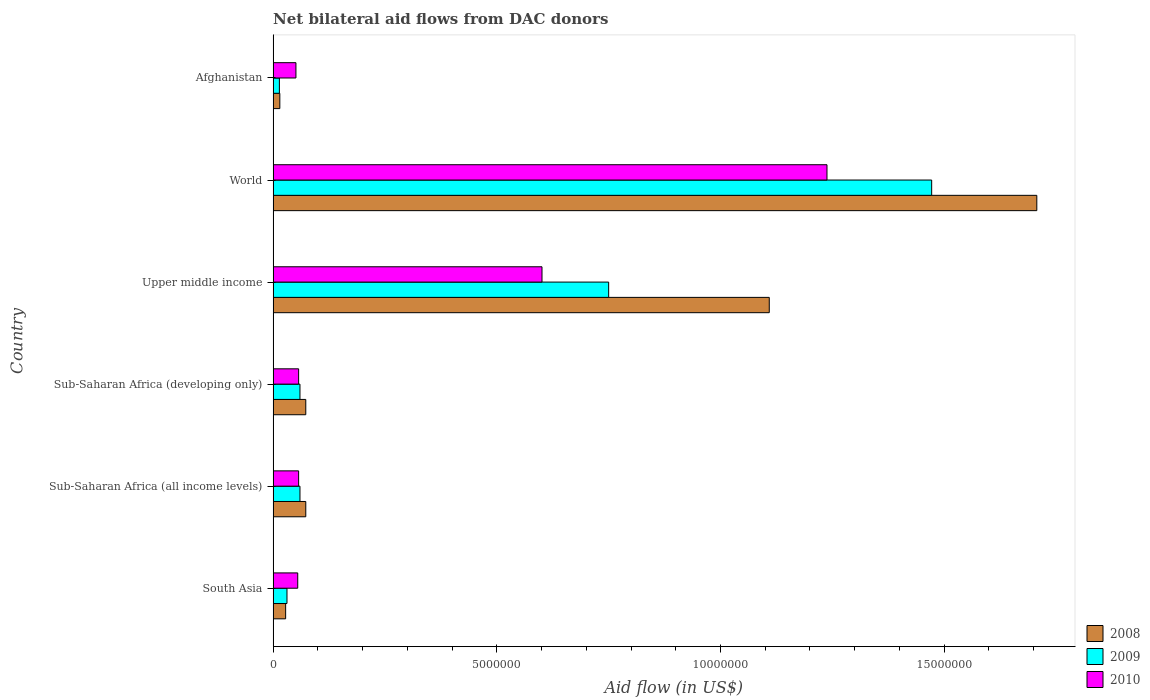How many groups of bars are there?
Provide a short and direct response. 6. Are the number of bars on each tick of the Y-axis equal?
Offer a terse response. Yes. How many bars are there on the 5th tick from the top?
Provide a succinct answer. 3. How many bars are there on the 2nd tick from the bottom?
Your response must be concise. 3. What is the label of the 5th group of bars from the top?
Offer a very short reply. Sub-Saharan Africa (all income levels). What is the net bilateral aid flow in 2009 in Sub-Saharan Africa (all income levels)?
Provide a succinct answer. 6.00e+05. Across all countries, what is the maximum net bilateral aid flow in 2008?
Your answer should be very brief. 1.71e+07. Across all countries, what is the minimum net bilateral aid flow in 2008?
Your response must be concise. 1.50e+05. In which country was the net bilateral aid flow in 2008 maximum?
Your answer should be very brief. World. In which country was the net bilateral aid flow in 2009 minimum?
Provide a succinct answer. Afghanistan. What is the total net bilateral aid flow in 2008 in the graph?
Keep it short and to the point. 3.00e+07. What is the average net bilateral aid flow in 2008 per country?
Make the answer very short. 5.01e+06. What is the difference between the net bilateral aid flow in 2008 and net bilateral aid flow in 2009 in Afghanistan?
Make the answer very short. 10000. What is the ratio of the net bilateral aid flow in 2009 in South Asia to that in Upper middle income?
Provide a succinct answer. 0.04. Is the net bilateral aid flow in 2010 in Sub-Saharan Africa (developing only) less than that in Upper middle income?
Your answer should be compact. Yes. What is the difference between the highest and the second highest net bilateral aid flow in 2010?
Your response must be concise. 6.37e+06. What is the difference between the highest and the lowest net bilateral aid flow in 2010?
Make the answer very short. 1.19e+07. In how many countries, is the net bilateral aid flow in 2010 greater than the average net bilateral aid flow in 2010 taken over all countries?
Give a very brief answer. 2. What does the 2nd bar from the top in South Asia represents?
Provide a succinct answer. 2009. What does the 1st bar from the bottom in South Asia represents?
Give a very brief answer. 2008. How many bars are there?
Make the answer very short. 18. Are all the bars in the graph horizontal?
Your response must be concise. Yes. How many countries are there in the graph?
Provide a short and direct response. 6. What is the difference between two consecutive major ticks on the X-axis?
Keep it short and to the point. 5.00e+06. Does the graph contain any zero values?
Your answer should be very brief. No. Where does the legend appear in the graph?
Your response must be concise. Bottom right. How are the legend labels stacked?
Your response must be concise. Vertical. What is the title of the graph?
Ensure brevity in your answer.  Net bilateral aid flows from DAC donors. Does "1997" appear as one of the legend labels in the graph?
Offer a terse response. No. What is the label or title of the X-axis?
Offer a terse response. Aid flow (in US$). What is the label or title of the Y-axis?
Keep it short and to the point. Country. What is the Aid flow (in US$) of 2010 in South Asia?
Your answer should be compact. 5.50e+05. What is the Aid flow (in US$) of 2008 in Sub-Saharan Africa (all income levels)?
Give a very brief answer. 7.30e+05. What is the Aid flow (in US$) of 2010 in Sub-Saharan Africa (all income levels)?
Provide a short and direct response. 5.70e+05. What is the Aid flow (in US$) in 2008 in Sub-Saharan Africa (developing only)?
Provide a short and direct response. 7.30e+05. What is the Aid flow (in US$) in 2010 in Sub-Saharan Africa (developing only)?
Keep it short and to the point. 5.70e+05. What is the Aid flow (in US$) of 2008 in Upper middle income?
Make the answer very short. 1.11e+07. What is the Aid flow (in US$) of 2009 in Upper middle income?
Provide a succinct answer. 7.50e+06. What is the Aid flow (in US$) of 2010 in Upper middle income?
Provide a short and direct response. 6.01e+06. What is the Aid flow (in US$) in 2008 in World?
Provide a short and direct response. 1.71e+07. What is the Aid flow (in US$) in 2009 in World?
Make the answer very short. 1.47e+07. What is the Aid flow (in US$) in 2010 in World?
Your answer should be compact. 1.24e+07. What is the Aid flow (in US$) of 2008 in Afghanistan?
Provide a short and direct response. 1.50e+05. What is the Aid flow (in US$) in 2010 in Afghanistan?
Offer a very short reply. 5.10e+05. Across all countries, what is the maximum Aid flow (in US$) in 2008?
Provide a short and direct response. 1.71e+07. Across all countries, what is the maximum Aid flow (in US$) in 2009?
Offer a very short reply. 1.47e+07. Across all countries, what is the maximum Aid flow (in US$) in 2010?
Your answer should be compact. 1.24e+07. Across all countries, what is the minimum Aid flow (in US$) in 2009?
Offer a very short reply. 1.40e+05. Across all countries, what is the minimum Aid flow (in US$) of 2010?
Give a very brief answer. 5.10e+05. What is the total Aid flow (in US$) of 2008 in the graph?
Your answer should be very brief. 3.00e+07. What is the total Aid flow (in US$) of 2009 in the graph?
Provide a short and direct response. 2.39e+07. What is the total Aid flow (in US$) of 2010 in the graph?
Your answer should be very brief. 2.06e+07. What is the difference between the Aid flow (in US$) in 2008 in South Asia and that in Sub-Saharan Africa (all income levels)?
Your answer should be very brief. -4.50e+05. What is the difference between the Aid flow (in US$) of 2009 in South Asia and that in Sub-Saharan Africa (all income levels)?
Keep it short and to the point. -2.90e+05. What is the difference between the Aid flow (in US$) of 2010 in South Asia and that in Sub-Saharan Africa (all income levels)?
Your answer should be very brief. -2.00e+04. What is the difference between the Aid flow (in US$) in 2008 in South Asia and that in Sub-Saharan Africa (developing only)?
Make the answer very short. -4.50e+05. What is the difference between the Aid flow (in US$) in 2010 in South Asia and that in Sub-Saharan Africa (developing only)?
Give a very brief answer. -2.00e+04. What is the difference between the Aid flow (in US$) in 2008 in South Asia and that in Upper middle income?
Your response must be concise. -1.08e+07. What is the difference between the Aid flow (in US$) in 2009 in South Asia and that in Upper middle income?
Give a very brief answer. -7.19e+06. What is the difference between the Aid flow (in US$) in 2010 in South Asia and that in Upper middle income?
Offer a terse response. -5.46e+06. What is the difference between the Aid flow (in US$) of 2008 in South Asia and that in World?
Provide a short and direct response. -1.68e+07. What is the difference between the Aid flow (in US$) in 2009 in South Asia and that in World?
Your answer should be compact. -1.44e+07. What is the difference between the Aid flow (in US$) of 2010 in South Asia and that in World?
Your response must be concise. -1.18e+07. What is the difference between the Aid flow (in US$) of 2008 in South Asia and that in Afghanistan?
Offer a terse response. 1.30e+05. What is the difference between the Aid flow (in US$) in 2009 in South Asia and that in Afghanistan?
Make the answer very short. 1.70e+05. What is the difference between the Aid flow (in US$) of 2008 in Sub-Saharan Africa (all income levels) and that in Upper middle income?
Give a very brief answer. -1.04e+07. What is the difference between the Aid flow (in US$) of 2009 in Sub-Saharan Africa (all income levels) and that in Upper middle income?
Keep it short and to the point. -6.90e+06. What is the difference between the Aid flow (in US$) of 2010 in Sub-Saharan Africa (all income levels) and that in Upper middle income?
Your answer should be compact. -5.44e+06. What is the difference between the Aid flow (in US$) of 2008 in Sub-Saharan Africa (all income levels) and that in World?
Give a very brief answer. -1.63e+07. What is the difference between the Aid flow (in US$) in 2009 in Sub-Saharan Africa (all income levels) and that in World?
Your answer should be compact. -1.41e+07. What is the difference between the Aid flow (in US$) in 2010 in Sub-Saharan Africa (all income levels) and that in World?
Offer a terse response. -1.18e+07. What is the difference between the Aid flow (in US$) in 2008 in Sub-Saharan Africa (all income levels) and that in Afghanistan?
Your response must be concise. 5.80e+05. What is the difference between the Aid flow (in US$) of 2009 in Sub-Saharan Africa (all income levels) and that in Afghanistan?
Make the answer very short. 4.60e+05. What is the difference between the Aid flow (in US$) in 2008 in Sub-Saharan Africa (developing only) and that in Upper middle income?
Make the answer very short. -1.04e+07. What is the difference between the Aid flow (in US$) in 2009 in Sub-Saharan Africa (developing only) and that in Upper middle income?
Your answer should be very brief. -6.90e+06. What is the difference between the Aid flow (in US$) of 2010 in Sub-Saharan Africa (developing only) and that in Upper middle income?
Provide a short and direct response. -5.44e+06. What is the difference between the Aid flow (in US$) in 2008 in Sub-Saharan Africa (developing only) and that in World?
Provide a short and direct response. -1.63e+07. What is the difference between the Aid flow (in US$) in 2009 in Sub-Saharan Africa (developing only) and that in World?
Offer a terse response. -1.41e+07. What is the difference between the Aid flow (in US$) of 2010 in Sub-Saharan Africa (developing only) and that in World?
Keep it short and to the point. -1.18e+07. What is the difference between the Aid flow (in US$) of 2008 in Sub-Saharan Africa (developing only) and that in Afghanistan?
Your answer should be very brief. 5.80e+05. What is the difference between the Aid flow (in US$) of 2009 in Sub-Saharan Africa (developing only) and that in Afghanistan?
Provide a succinct answer. 4.60e+05. What is the difference between the Aid flow (in US$) of 2008 in Upper middle income and that in World?
Make the answer very short. -5.98e+06. What is the difference between the Aid flow (in US$) of 2009 in Upper middle income and that in World?
Provide a short and direct response. -7.22e+06. What is the difference between the Aid flow (in US$) of 2010 in Upper middle income and that in World?
Your response must be concise. -6.37e+06. What is the difference between the Aid flow (in US$) of 2008 in Upper middle income and that in Afghanistan?
Keep it short and to the point. 1.09e+07. What is the difference between the Aid flow (in US$) in 2009 in Upper middle income and that in Afghanistan?
Your response must be concise. 7.36e+06. What is the difference between the Aid flow (in US$) in 2010 in Upper middle income and that in Afghanistan?
Offer a terse response. 5.50e+06. What is the difference between the Aid flow (in US$) in 2008 in World and that in Afghanistan?
Give a very brief answer. 1.69e+07. What is the difference between the Aid flow (in US$) of 2009 in World and that in Afghanistan?
Your response must be concise. 1.46e+07. What is the difference between the Aid flow (in US$) in 2010 in World and that in Afghanistan?
Offer a very short reply. 1.19e+07. What is the difference between the Aid flow (in US$) in 2008 in South Asia and the Aid flow (in US$) in 2009 in Sub-Saharan Africa (all income levels)?
Offer a very short reply. -3.20e+05. What is the difference between the Aid flow (in US$) of 2009 in South Asia and the Aid flow (in US$) of 2010 in Sub-Saharan Africa (all income levels)?
Give a very brief answer. -2.60e+05. What is the difference between the Aid flow (in US$) in 2008 in South Asia and the Aid flow (in US$) in 2009 in Sub-Saharan Africa (developing only)?
Provide a short and direct response. -3.20e+05. What is the difference between the Aid flow (in US$) in 2008 in South Asia and the Aid flow (in US$) in 2009 in Upper middle income?
Offer a terse response. -7.22e+06. What is the difference between the Aid flow (in US$) in 2008 in South Asia and the Aid flow (in US$) in 2010 in Upper middle income?
Your response must be concise. -5.73e+06. What is the difference between the Aid flow (in US$) of 2009 in South Asia and the Aid flow (in US$) of 2010 in Upper middle income?
Make the answer very short. -5.70e+06. What is the difference between the Aid flow (in US$) in 2008 in South Asia and the Aid flow (in US$) in 2009 in World?
Offer a very short reply. -1.44e+07. What is the difference between the Aid flow (in US$) in 2008 in South Asia and the Aid flow (in US$) in 2010 in World?
Your answer should be very brief. -1.21e+07. What is the difference between the Aid flow (in US$) of 2009 in South Asia and the Aid flow (in US$) of 2010 in World?
Ensure brevity in your answer.  -1.21e+07. What is the difference between the Aid flow (in US$) in 2008 in South Asia and the Aid flow (in US$) in 2009 in Afghanistan?
Give a very brief answer. 1.40e+05. What is the difference between the Aid flow (in US$) in 2008 in South Asia and the Aid flow (in US$) in 2010 in Afghanistan?
Your answer should be very brief. -2.30e+05. What is the difference between the Aid flow (in US$) in 2008 in Sub-Saharan Africa (all income levels) and the Aid flow (in US$) in 2009 in Sub-Saharan Africa (developing only)?
Keep it short and to the point. 1.30e+05. What is the difference between the Aid flow (in US$) of 2008 in Sub-Saharan Africa (all income levels) and the Aid flow (in US$) of 2010 in Sub-Saharan Africa (developing only)?
Offer a very short reply. 1.60e+05. What is the difference between the Aid flow (in US$) of 2008 in Sub-Saharan Africa (all income levels) and the Aid flow (in US$) of 2009 in Upper middle income?
Make the answer very short. -6.77e+06. What is the difference between the Aid flow (in US$) of 2008 in Sub-Saharan Africa (all income levels) and the Aid flow (in US$) of 2010 in Upper middle income?
Make the answer very short. -5.28e+06. What is the difference between the Aid flow (in US$) of 2009 in Sub-Saharan Africa (all income levels) and the Aid flow (in US$) of 2010 in Upper middle income?
Your answer should be very brief. -5.41e+06. What is the difference between the Aid flow (in US$) of 2008 in Sub-Saharan Africa (all income levels) and the Aid flow (in US$) of 2009 in World?
Your response must be concise. -1.40e+07. What is the difference between the Aid flow (in US$) of 2008 in Sub-Saharan Africa (all income levels) and the Aid flow (in US$) of 2010 in World?
Provide a succinct answer. -1.16e+07. What is the difference between the Aid flow (in US$) in 2009 in Sub-Saharan Africa (all income levels) and the Aid flow (in US$) in 2010 in World?
Your answer should be very brief. -1.18e+07. What is the difference between the Aid flow (in US$) of 2008 in Sub-Saharan Africa (all income levels) and the Aid flow (in US$) of 2009 in Afghanistan?
Keep it short and to the point. 5.90e+05. What is the difference between the Aid flow (in US$) of 2008 in Sub-Saharan Africa (all income levels) and the Aid flow (in US$) of 2010 in Afghanistan?
Keep it short and to the point. 2.20e+05. What is the difference between the Aid flow (in US$) in 2008 in Sub-Saharan Africa (developing only) and the Aid flow (in US$) in 2009 in Upper middle income?
Your response must be concise. -6.77e+06. What is the difference between the Aid flow (in US$) of 2008 in Sub-Saharan Africa (developing only) and the Aid flow (in US$) of 2010 in Upper middle income?
Ensure brevity in your answer.  -5.28e+06. What is the difference between the Aid flow (in US$) in 2009 in Sub-Saharan Africa (developing only) and the Aid flow (in US$) in 2010 in Upper middle income?
Provide a short and direct response. -5.41e+06. What is the difference between the Aid flow (in US$) in 2008 in Sub-Saharan Africa (developing only) and the Aid flow (in US$) in 2009 in World?
Your answer should be compact. -1.40e+07. What is the difference between the Aid flow (in US$) in 2008 in Sub-Saharan Africa (developing only) and the Aid flow (in US$) in 2010 in World?
Offer a very short reply. -1.16e+07. What is the difference between the Aid flow (in US$) in 2009 in Sub-Saharan Africa (developing only) and the Aid flow (in US$) in 2010 in World?
Keep it short and to the point. -1.18e+07. What is the difference between the Aid flow (in US$) in 2008 in Sub-Saharan Africa (developing only) and the Aid flow (in US$) in 2009 in Afghanistan?
Keep it short and to the point. 5.90e+05. What is the difference between the Aid flow (in US$) in 2008 in Sub-Saharan Africa (developing only) and the Aid flow (in US$) in 2010 in Afghanistan?
Your answer should be very brief. 2.20e+05. What is the difference between the Aid flow (in US$) in 2009 in Sub-Saharan Africa (developing only) and the Aid flow (in US$) in 2010 in Afghanistan?
Make the answer very short. 9.00e+04. What is the difference between the Aid flow (in US$) of 2008 in Upper middle income and the Aid flow (in US$) of 2009 in World?
Provide a short and direct response. -3.63e+06. What is the difference between the Aid flow (in US$) of 2008 in Upper middle income and the Aid flow (in US$) of 2010 in World?
Give a very brief answer. -1.29e+06. What is the difference between the Aid flow (in US$) in 2009 in Upper middle income and the Aid flow (in US$) in 2010 in World?
Your answer should be compact. -4.88e+06. What is the difference between the Aid flow (in US$) in 2008 in Upper middle income and the Aid flow (in US$) in 2009 in Afghanistan?
Keep it short and to the point. 1.10e+07. What is the difference between the Aid flow (in US$) in 2008 in Upper middle income and the Aid flow (in US$) in 2010 in Afghanistan?
Ensure brevity in your answer.  1.06e+07. What is the difference between the Aid flow (in US$) in 2009 in Upper middle income and the Aid flow (in US$) in 2010 in Afghanistan?
Give a very brief answer. 6.99e+06. What is the difference between the Aid flow (in US$) of 2008 in World and the Aid flow (in US$) of 2009 in Afghanistan?
Provide a succinct answer. 1.69e+07. What is the difference between the Aid flow (in US$) in 2008 in World and the Aid flow (in US$) in 2010 in Afghanistan?
Make the answer very short. 1.66e+07. What is the difference between the Aid flow (in US$) of 2009 in World and the Aid flow (in US$) of 2010 in Afghanistan?
Provide a succinct answer. 1.42e+07. What is the average Aid flow (in US$) of 2008 per country?
Provide a short and direct response. 5.01e+06. What is the average Aid flow (in US$) of 2009 per country?
Your answer should be very brief. 3.98e+06. What is the average Aid flow (in US$) of 2010 per country?
Offer a terse response. 3.43e+06. What is the difference between the Aid flow (in US$) in 2008 and Aid flow (in US$) in 2009 in Sub-Saharan Africa (all income levels)?
Give a very brief answer. 1.30e+05. What is the difference between the Aid flow (in US$) of 2009 and Aid flow (in US$) of 2010 in Sub-Saharan Africa (all income levels)?
Offer a very short reply. 3.00e+04. What is the difference between the Aid flow (in US$) of 2008 and Aid flow (in US$) of 2009 in Sub-Saharan Africa (developing only)?
Ensure brevity in your answer.  1.30e+05. What is the difference between the Aid flow (in US$) of 2008 and Aid flow (in US$) of 2010 in Sub-Saharan Africa (developing only)?
Offer a very short reply. 1.60e+05. What is the difference between the Aid flow (in US$) of 2008 and Aid flow (in US$) of 2009 in Upper middle income?
Make the answer very short. 3.59e+06. What is the difference between the Aid flow (in US$) in 2008 and Aid flow (in US$) in 2010 in Upper middle income?
Offer a terse response. 5.08e+06. What is the difference between the Aid flow (in US$) in 2009 and Aid flow (in US$) in 2010 in Upper middle income?
Offer a terse response. 1.49e+06. What is the difference between the Aid flow (in US$) in 2008 and Aid flow (in US$) in 2009 in World?
Keep it short and to the point. 2.35e+06. What is the difference between the Aid flow (in US$) in 2008 and Aid flow (in US$) in 2010 in World?
Your response must be concise. 4.69e+06. What is the difference between the Aid flow (in US$) in 2009 and Aid flow (in US$) in 2010 in World?
Give a very brief answer. 2.34e+06. What is the difference between the Aid flow (in US$) of 2008 and Aid flow (in US$) of 2009 in Afghanistan?
Ensure brevity in your answer.  10000. What is the difference between the Aid flow (in US$) in 2008 and Aid flow (in US$) in 2010 in Afghanistan?
Your answer should be compact. -3.60e+05. What is the difference between the Aid flow (in US$) in 2009 and Aid flow (in US$) in 2010 in Afghanistan?
Make the answer very short. -3.70e+05. What is the ratio of the Aid flow (in US$) of 2008 in South Asia to that in Sub-Saharan Africa (all income levels)?
Keep it short and to the point. 0.38. What is the ratio of the Aid flow (in US$) in 2009 in South Asia to that in Sub-Saharan Africa (all income levels)?
Your answer should be very brief. 0.52. What is the ratio of the Aid flow (in US$) in 2010 in South Asia to that in Sub-Saharan Africa (all income levels)?
Provide a succinct answer. 0.96. What is the ratio of the Aid flow (in US$) in 2008 in South Asia to that in Sub-Saharan Africa (developing only)?
Keep it short and to the point. 0.38. What is the ratio of the Aid flow (in US$) of 2009 in South Asia to that in Sub-Saharan Africa (developing only)?
Offer a very short reply. 0.52. What is the ratio of the Aid flow (in US$) of 2010 in South Asia to that in Sub-Saharan Africa (developing only)?
Your response must be concise. 0.96. What is the ratio of the Aid flow (in US$) in 2008 in South Asia to that in Upper middle income?
Your answer should be very brief. 0.03. What is the ratio of the Aid flow (in US$) in 2009 in South Asia to that in Upper middle income?
Your answer should be very brief. 0.04. What is the ratio of the Aid flow (in US$) of 2010 in South Asia to that in Upper middle income?
Ensure brevity in your answer.  0.09. What is the ratio of the Aid flow (in US$) in 2008 in South Asia to that in World?
Offer a terse response. 0.02. What is the ratio of the Aid flow (in US$) in 2009 in South Asia to that in World?
Keep it short and to the point. 0.02. What is the ratio of the Aid flow (in US$) of 2010 in South Asia to that in World?
Provide a succinct answer. 0.04. What is the ratio of the Aid flow (in US$) of 2008 in South Asia to that in Afghanistan?
Ensure brevity in your answer.  1.87. What is the ratio of the Aid flow (in US$) in 2009 in South Asia to that in Afghanistan?
Provide a short and direct response. 2.21. What is the ratio of the Aid flow (in US$) of 2010 in South Asia to that in Afghanistan?
Give a very brief answer. 1.08. What is the ratio of the Aid flow (in US$) in 2008 in Sub-Saharan Africa (all income levels) to that in Sub-Saharan Africa (developing only)?
Provide a short and direct response. 1. What is the ratio of the Aid flow (in US$) of 2010 in Sub-Saharan Africa (all income levels) to that in Sub-Saharan Africa (developing only)?
Keep it short and to the point. 1. What is the ratio of the Aid flow (in US$) of 2008 in Sub-Saharan Africa (all income levels) to that in Upper middle income?
Offer a very short reply. 0.07. What is the ratio of the Aid flow (in US$) in 2009 in Sub-Saharan Africa (all income levels) to that in Upper middle income?
Offer a very short reply. 0.08. What is the ratio of the Aid flow (in US$) of 2010 in Sub-Saharan Africa (all income levels) to that in Upper middle income?
Your response must be concise. 0.09. What is the ratio of the Aid flow (in US$) of 2008 in Sub-Saharan Africa (all income levels) to that in World?
Give a very brief answer. 0.04. What is the ratio of the Aid flow (in US$) of 2009 in Sub-Saharan Africa (all income levels) to that in World?
Offer a terse response. 0.04. What is the ratio of the Aid flow (in US$) of 2010 in Sub-Saharan Africa (all income levels) to that in World?
Give a very brief answer. 0.05. What is the ratio of the Aid flow (in US$) of 2008 in Sub-Saharan Africa (all income levels) to that in Afghanistan?
Keep it short and to the point. 4.87. What is the ratio of the Aid flow (in US$) of 2009 in Sub-Saharan Africa (all income levels) to that in Afghanistan?
Your answer should be very brief. 4.29. What is the ratio of the Aid flow (in US$) of 2010 in Sub-Saharan Africa (all income levels) to that in Afghanistan?
Offer a very short reply. 1.12. What is the ratio of the Aid flow (in US$) of 2008 in Sub-Saharan Africa (developing only) to that in Upper middle income?
Provide a short and direct response. 0.07. What is the ratio of the Aid flow (in US$) of 2009 in Sub-Saharan Africa (developing only) to that in Upper middle income?
Your response must be concise. 0.08. What is the ratio of the Aid flow (in US$) in 2010 in Sub-Saharan Africa (developing only) to that in Upper middle income?
Your response must be concise. 0.09. What is the ratio of the Aid flow (in US$) in 2008 in Sub-Saharan Africa (developing only) to that in World?
Offer a terse response. 0.04. What is the ratio of the Aid flow (in US$) in 2009 in Sub-Saharan Africa (developing only) to that in World?
Provide a short and direct response. 0.04. What is the ratio of the Aid flow (in US$) of 2010 in Sub-Saharan Africa (developing only) to that in World?
Keep it short and to the point. 0.05. What is the ratio of the Aid flow (in US$) in 2008 in Sub-Saharan Africa (developing only) to that in Afghanistan?
Provide a short and direct response. 4.87. What is the ratio of the Aid flow (in US$) of 2009 in Sub-Saharan Africa (developing only) to that in Afghanistan?
Give a very brief answer. 4.29. What is the ratio of the Aid flow (in US$) in 2010 in Sub-Saharan Africa (developing only) to that in Afghanistan?
Offer a terse response. 1.12. What is the ratio of the Aid flow (in US$) of 2008 in Upper middle income to that in World?
Keep it short and to the point. 0.65. What is the ratio of the Aid flow (in US$) in 2009 in Upper middle income to that in World?
Your response must be concise. 0.51. What is the ratio of the Aid flow (in US$) in 2010 in Upper middle income to that in World?
Keep it short and to the point. 0.49. What is the ratio of the Aid flow (in US$) of 2008 in Upper middle income to that in Afghanistan?
Make the answer very short. 73.93. What is the ratio of the Aid flow (in US$) in 2009 in Upper middle income to that in Afghanistan?
Make the answer very short. 53.57. What is the ratio of the Aid flow (in US$) of 2010 in Upper middle income to that in Afghanistan?
Your answer should be very brief. 11.78. What is the ratio of the Aid flow (in US$) of 2008 in World to that in Afghanistan?
Provide a short and direct response. 113.8. What is the ratio of the Aid flow (in US$) in 2009 in World to that in Afghanistan?
Give a very brief answer. 105.14. What is the ratio of the Aid flow (in US$) of 2010 in World to that in Afghanistan?
Keep it short and to the point. 24.27. What is the difference between the highest and the second highest Aid flow (in US$) of 2008?
Your response must be concise. 5.98e+06. What is the difference between the highest and the second highest Aid flow (in US$) of 2009?
Give a very brief answer. 7.22e+06. What is the difference between the highest and the second highest Aid flow (in US$) of 2010?
Provide a succinct answer. 6.37e+06. What is the difference between the highest and the lowest Aid flow (in US$) of 2008?
Offer a terse response. 1.69e+07. What is the difference between the highest and the lowest Aid flow (in US$) of 2009?
Your answer should be very brief. 1.46e+07. What is the difference between the highest and the lowest Aid flow (in US$) in 2010?
Keep it short and to the point. 1.19e+07. 